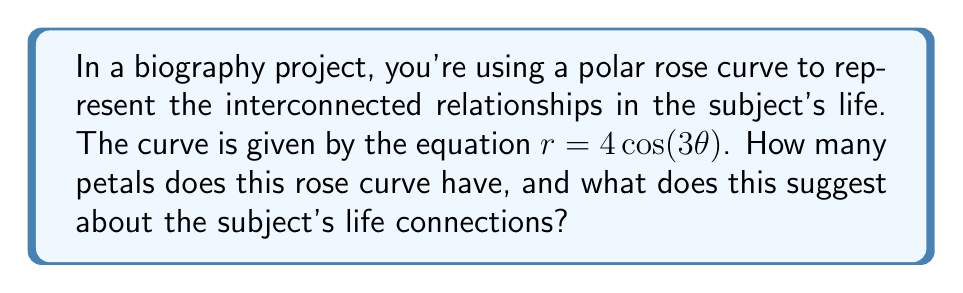Can you solve this math problem? To analyze the shape of a polar rose curve and determine the number of petals, we need to follow these steps:

1. Identify the general form of a polar rose curve:
   The general equation for a polar rose is $r = a \cos(n\theta)$ or $r = a \sin(n\theta)$, where $a$ is the amplitude and $n$ is the frequency.

2. Compare our equation to the general form:
   Our equation $r = 4\cos(3\theta)$ matches the cosine form with $a = 4$ and $n = 3$.

3. Determine the number of petals:
   - If $n$ is odd, the number of petals is $n$.
   - If $n$ is even, the number of petals is $2n$.

   In our case, $n = 3$, which is odd, so the number of petals is 3.

4. Visualize the curve:
   [asy]
   import graph;
   size(200);
   real r(real t) {return 4*cos(3*t);}
   path g=polargraph(r,0,2pi,300);
   draw(g,red);
   draw(circle(0,4),gray+dashed);
   xaxis(Arrow);
   yaxis(Arrow);
   [/asy]

5. Interpret the result:
   The three petals of the rose curve suggest that the biographical subject's life can be divided into three main interconnected areas or phases. This could represent:
   - Three major life periods (e.g., early life, career, later years)
   - Three primary relationship types (e.g., family, friends, professional)
   - Three main areas of influence or achievement

   The symmetry of the curve implies a balance between these aspects of the subject's life.
Answer: The polar rose curve has 3 petals, suggesting that the biographical subject's life can be characterized by three main interconnected areas or phases, which could represent major life periods, primary relationship types, or main areas of influence or achievement. 